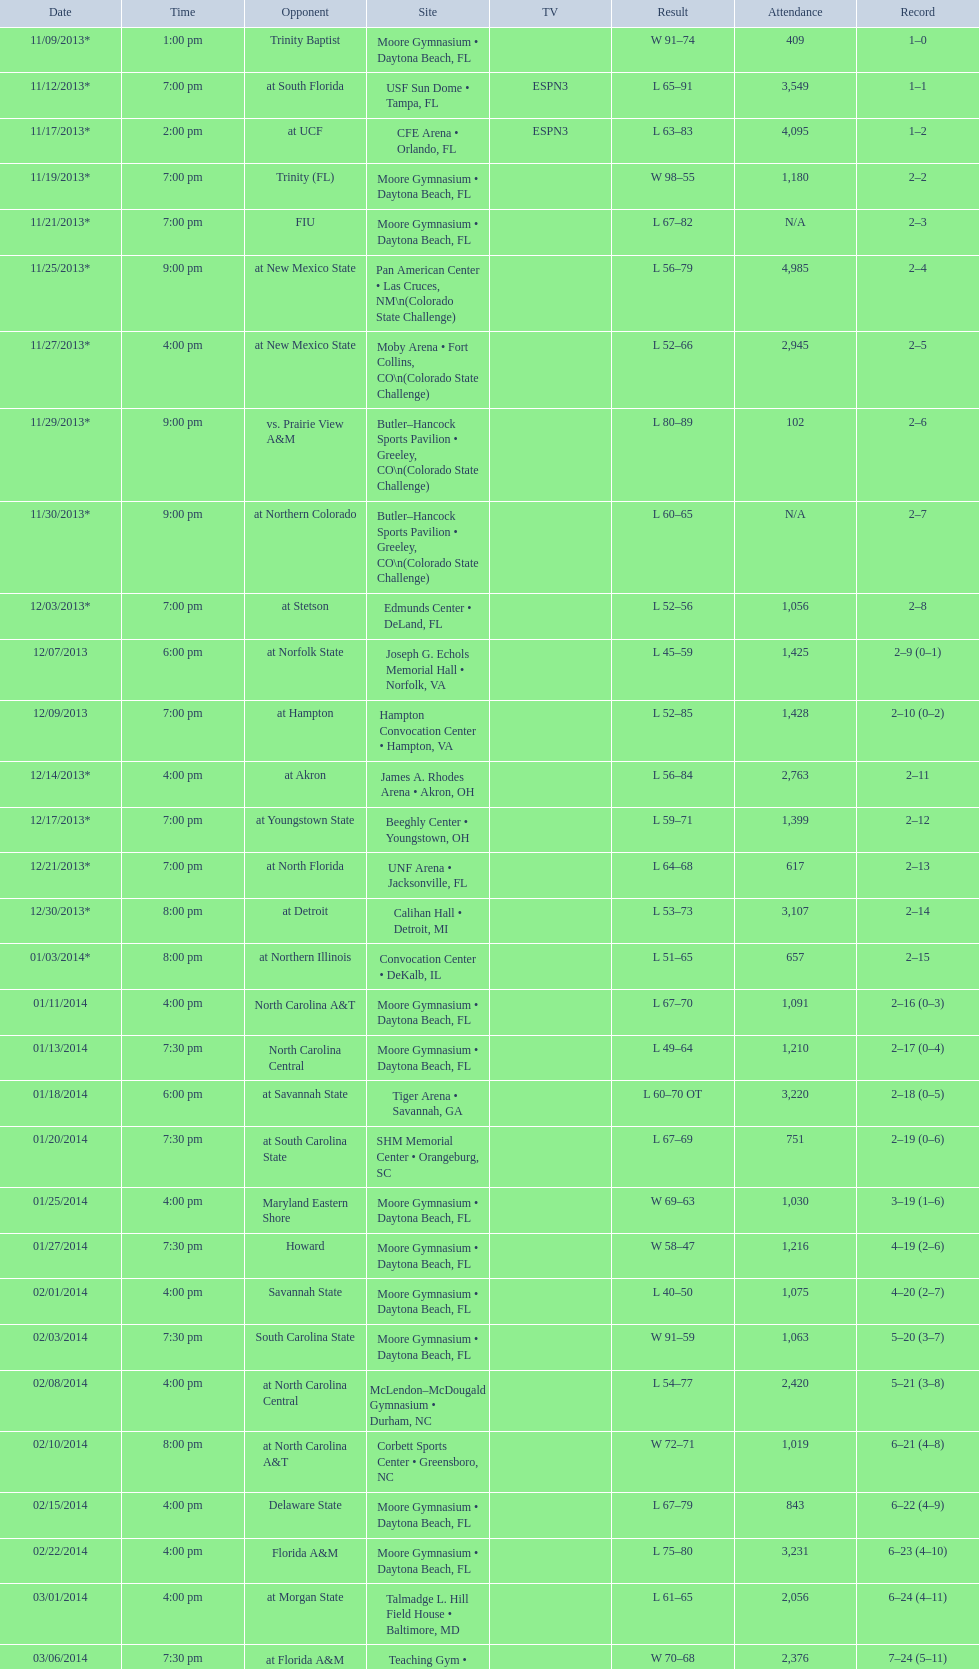Did the 11/19/2013 game attract more than 1,000 attendees? Yes. 